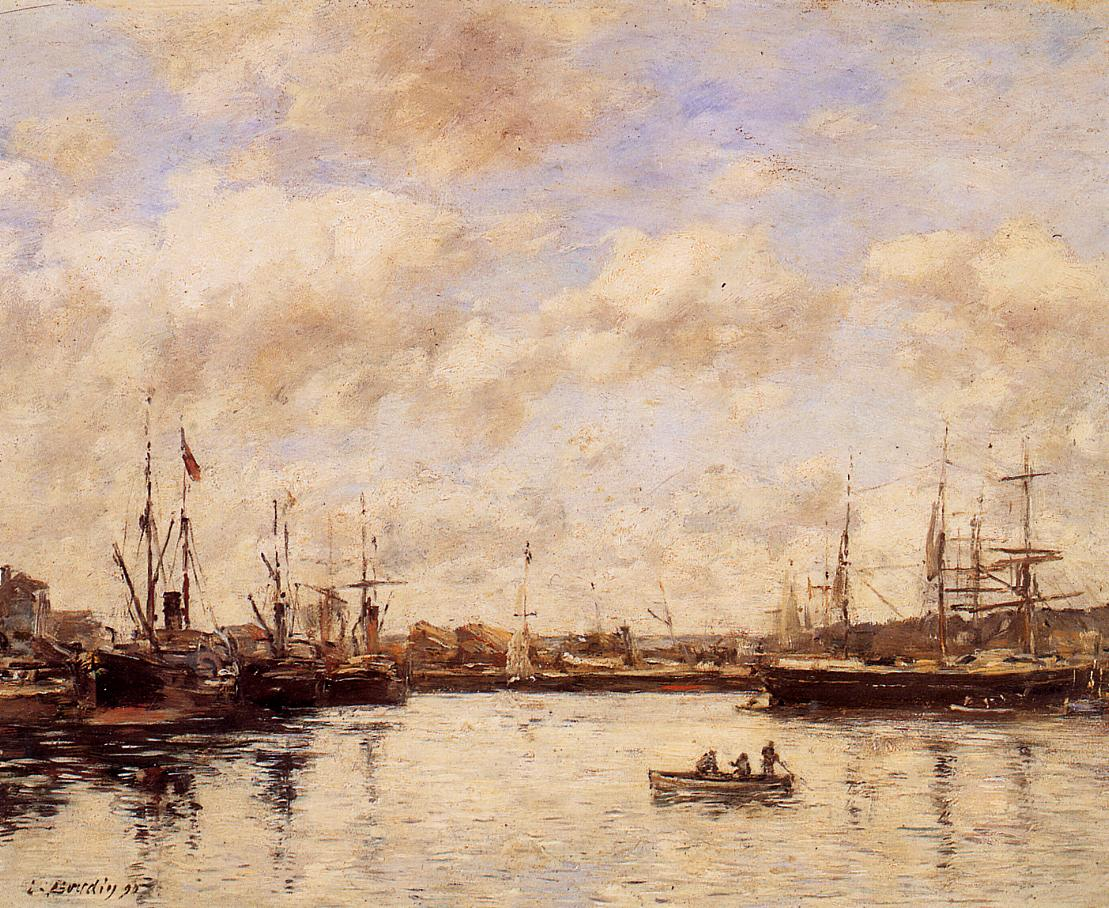What season do you think it is in this painting? The painting seems to depict a scene in late summer or early autumn. The muted tones and calm, reflective water suggest a time of year when the weather is mild and the days are slowly getting shorter. The tranquility and absence of vibrant spring or harsh winter colors further support the idea of a serene, transitional period. Can you describe a day in the life of this harbor during this season? A day in the harbor during late summer or early autumn might start with a soft, hazy dawn, where the sky gradually lightens in pale blues and pinks. Fishermen and sailors go about their tasks quietly, preparing their boats for the day's activities. As the sun rises higher, the harbor becomes a scene of subdued activity, with ships coming and going, and the quiet clinking of ropes and sails. By midday, the light is strong, casting gentle reflections on the calm water and highlighting the soft, muted hues of the scene. The day winds down with a golden hour, where the light takes on a warm, amber glow, adding a touch of magic to an otherwise peaceful day. Finally, the evening settles in with the sky slowly darkening, and the harbor returns to its serene stillness, with the occasional soft hum of quiet conversations and the gentle lapping of water. If you could add one more element to this painting, what would it be and why? If I could add one more element to this painting, it would be a faint rainbow arcing across the sky. This subtle addition would introduce a delicate touch of color and wonder without disrupting the overall tranquility of the scene. The rainbow could symbolize hope and the beauty found in small moments, adding a gentle contrast to the muted tones and enhancing the dreamlike quality of the painting. 